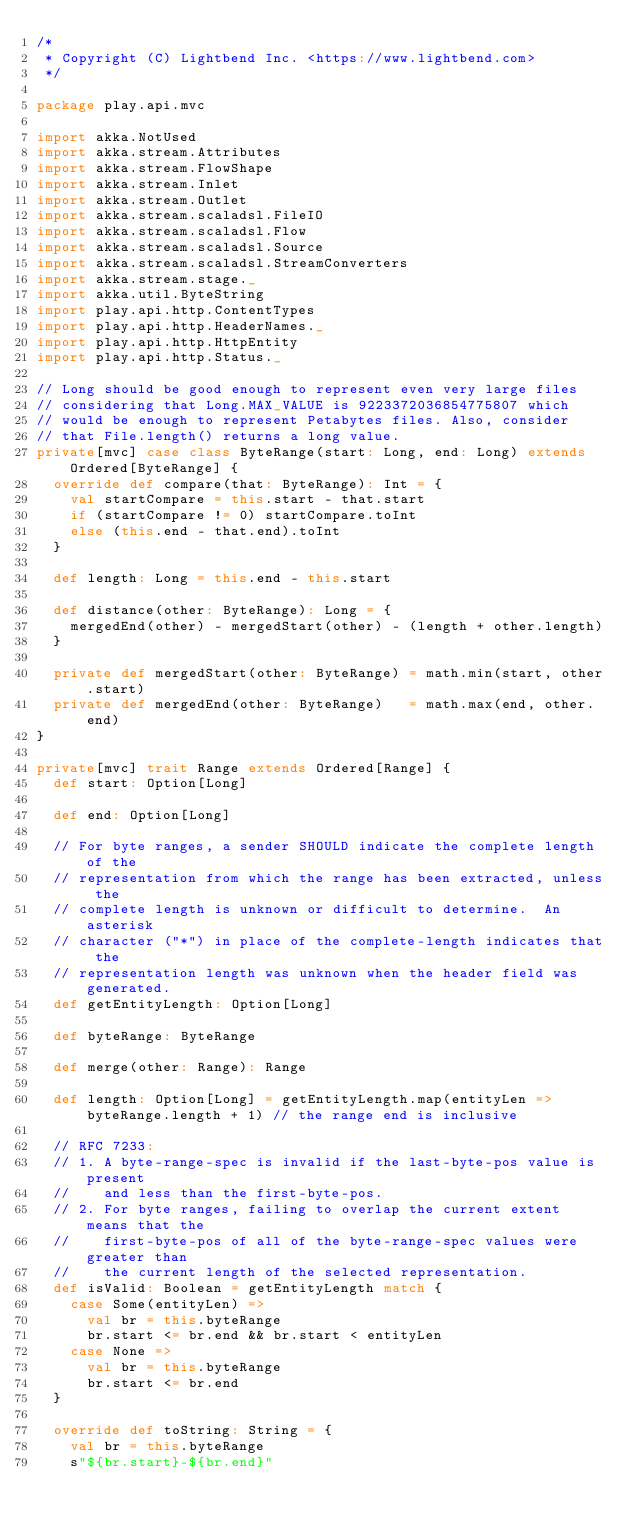Convert code to text. <code><loc_0><loc_0><loc_500><loc_500><_Scala_>/*
 * Copyright (C) Lightbend Inc. <https://www.lightbend.com>
 */

package play.api.mvc

import akka.NotUsed
import akka.stream.Attributes
import akka.stream.FlowShape
import akka.stream.Inlet
import akka.stream.Outlet
import akka.stream.scaladsl.FileIO
import akka.stream.scaladsl.Flow
import akka.stream.scaladsl.Source
import akka.stream.scaladsl.StreamConverters
import akka.stream.stage._
import akka.util.ByteString
import play.api.http.ContentTypes
import play.api.http.HeaderNames._
import play.api.http.HttpEntity
import play.api.http.Status._

// Long should be good enough to represent even very large files
// considering that Long.MAX_VALUE is 9223372036854775807 which
// would be enough to represent Petabytes files. Also, consider
// that File.length() returns a long value.
private[mvc] case class ByteRange(start: Long, end: Long) extends Ordered[ByteRange] {
  override def compare(that: ByteRange): Int = {
    val startCompare = this.start - that.start
    if (startCompare != 0) startCompare.toInt
    else (this.end - that.end).toInt
  }

  def length: Long = this.end - this.start

  def distance(other: ByteRange): Long = {
    mergedEnd(other) - mergedStart(other) - (length + other.length)
  }

  private def mergedStart(other: ByteRange) = math.min(start, other.start)
  private def mergedEnd(other: ByteRange)   = math.max(end, other.end)
}

private[mvc] trait Range extends Ordered[Range] {
  def start: Option[Long]

  def end: Option[Long]

  // For byte ranges, a sender SHOULD indicate the complete length of the
  // representation from which the range has been extracted, unless the
  // complete length is unknown or difficult to determine.  An asterisk
  // character ("*") in place of the complete-length indicates that the
  // representation length was unknown when the header field was generated.
  def getEntityLength: Option[Long]

  def byteRange: ByteRange

  def merge(other: Range): Range

  def length: Option[Long] = getEntityLength.map(entityLen => byteRange.length + 1) // the range end is inclusive

  // RFC 7233:
  // 1. A byte-range-spec is invalid if the last-byte-pos value is present
  //    and less than the first-byte-pos.
  // 2. For byte ranges, failing to overlap the current extent means that the
  //    first-byte-pos of all of the byte-range-spec values were greater than
  //    the current length of the selected representation.
  def isValid: Boolean = getEntityLength match {
    case Some(entityLen) =>
      val br = this.byteRange
      br.start <= br.end && br.start < entityLen
    case None =>
      val br = this.byteRange
      br.start <= br.end
  }

  override def toString: String = {
    val br = this.byteRange
    s"${br.start}-${br.end}"</code> 